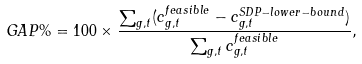<formula> <loc_0><loc_0><loc_500><loc_500>G A P \% = 1 0 0 \times \frac { \sum _ { g , t } ( c ^ { f e a s i b l e } _ { g , t } - c ^ { S D P - l o w e r - b o u n d } _ { g , t } ) } { \sum _ { g , t } c ^ { f e a s i b l e } _ { g , t } } ,</formula> 